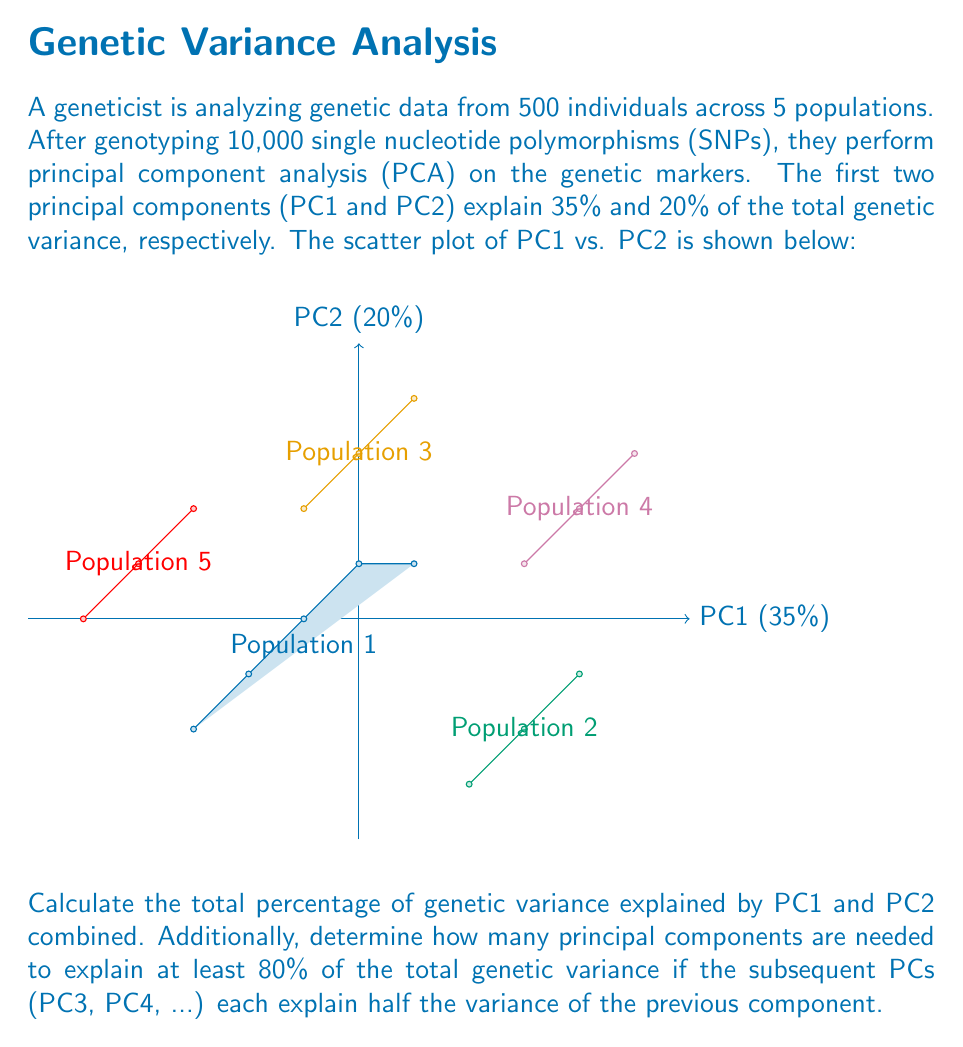Teach me how to tackle this problem. Let's approach this problem step-by-step:

1. Calculate the total variance explained by PC1 and PC2:
   PC1 explains 35% of the variance
   PC2 explains 20% of the variance
   Total variance explained = 35% + 20% = 55%

2. To determine how many PCs are needed to explain at least 80% of the variance:
   We need to calculate the cumulative variance explained by adding PCs until we reach or exceed 80%.

   Given: Each subsequent PC explains half the variance of the previous component.

   Let's calculate the variance explained by each PC:
   PC1: 35%
   PC2: 20%
   PC3: 20% / 2 = 10%
   PC4: 10% / 2 = 5%
   PC5: 5% / 2 = 2.5%
   ...

3. Now, let's sum the cumulative variance:
   PC1: 35% (cumulative: 35%)
   PC1 + PC2: 35% + 20% = 55% (cumulative: 55%)
   PC1 + PC2 + PC3: 55% + 10% = 65% (cumulative: 65%)
   PC1 + PC2 + PC3 + PC4: 65% + 5% = 70% (cumulative: 70%)
   PC1 + PC2 + PC3 + PC4 + PC5: 70% + 2.5% = 72.5% (cumulative: 72.5%)
   PC1 + PC2 + PC3 + PC4 + PC5 + PC6: 72.5% + 1.25% = 73.75% (cumulative: 73.75%)
   PC1 + PC2 + PC3 + PC4 + PC5 + PC6 + PC7: 73.75% + 0.625% = 74.375% (cumulative: 74.375%)
   PC1 + PC2 + PC3 + PC4 + PC5 + PC6 + PC7 + PC8: 74.375% + 0.3125% = 74.6875% (cumulative: 74.6875%)
   PC1 + PC2 + PC3 + PC4 + PC5 + PC6 + PC7 + PC8 + PC9: 74.6875% + 0.15625% = 74.84375% (cumulative: 74.84375%)
   PC1 + PC2 + PC3 + PC4 + PC5 + PC6 + PC7 + PC8 + PC9 + PC10: 74.84375% + 0.078125% = 74.921875% (cumulative: 74.921875%)

   We need to continue this process until we reach or exceed 80%.

   After calculating further, we find that we need 23 principal components to exceed 80% of the total genetic variance.
Answer: 55%; 23 principal components 